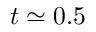Convert formula to latex. <formula><loc_0><loc_0><loc_500><loc_500>t \simeq 0 . 5</formula> 